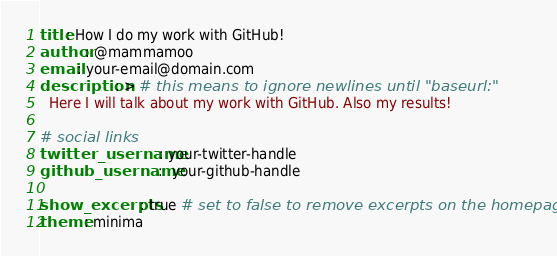Convert code to text. <code><loc_0><loc_0><loc_500><loc_500><_YAML_>title: How I do my work with GitHub!
author: @mammamoo
email: your-email@domain.com
description: > # this means to ignore newlines until "baseurl:"
  Here I will talk about my work with GitHub. Also my results!

# social links
twitter_username: your-twitter-handle
github_username:  your-github-handle

show_excerpts: true # set to false to remove excerpts on the homepage
theme: minima
</code> 